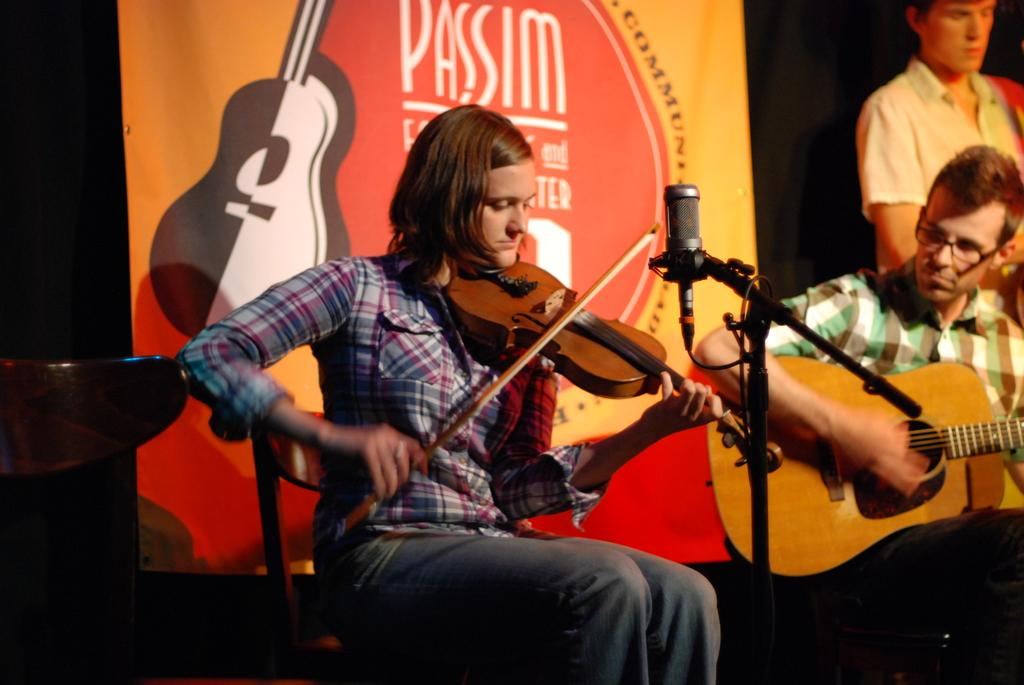Who is the main subject in the image? There is a girl in the image. What is the girl doing in the image? The girl is sitting on a chair and playing a musical instrument. What object is in front of the girl? There is a microphone in front of the girl. Who else is present in the image? There is a guy in the image. What is the guy doing in the image? The guy is holding a musical instrument. What type of bulb is hanging above the girl in the image? There is no bulb present in the image. What selection of musical instruments can be seen in the image? The image only shows the girl playing one musical instrument and the guy holding another, so it is not possible to determine a selection of musical instruments. 